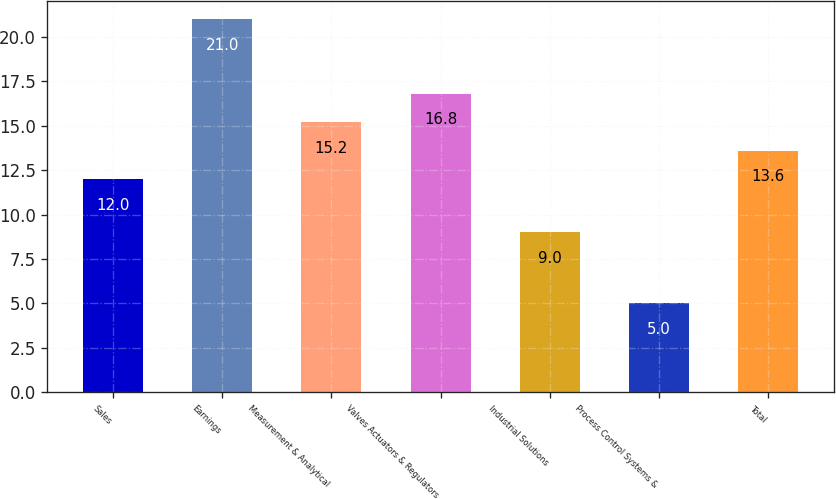Convert chart. <chart><loc_0><loc_0><loc_500><loc_500><bar_chart><fcel>Sales<fcel>Earnings<fcel>Measurement & Analytical<fcel>Valves Actuators & Regulators<fcel>Industrial Solutions<fcel>Process Control Systems &<fcel>Total<nl><fcel>12<fcel>21<fcel>15.2<fcel>16.8<fcel>9<fcel>5<fcel>13.6<nl></chart> 